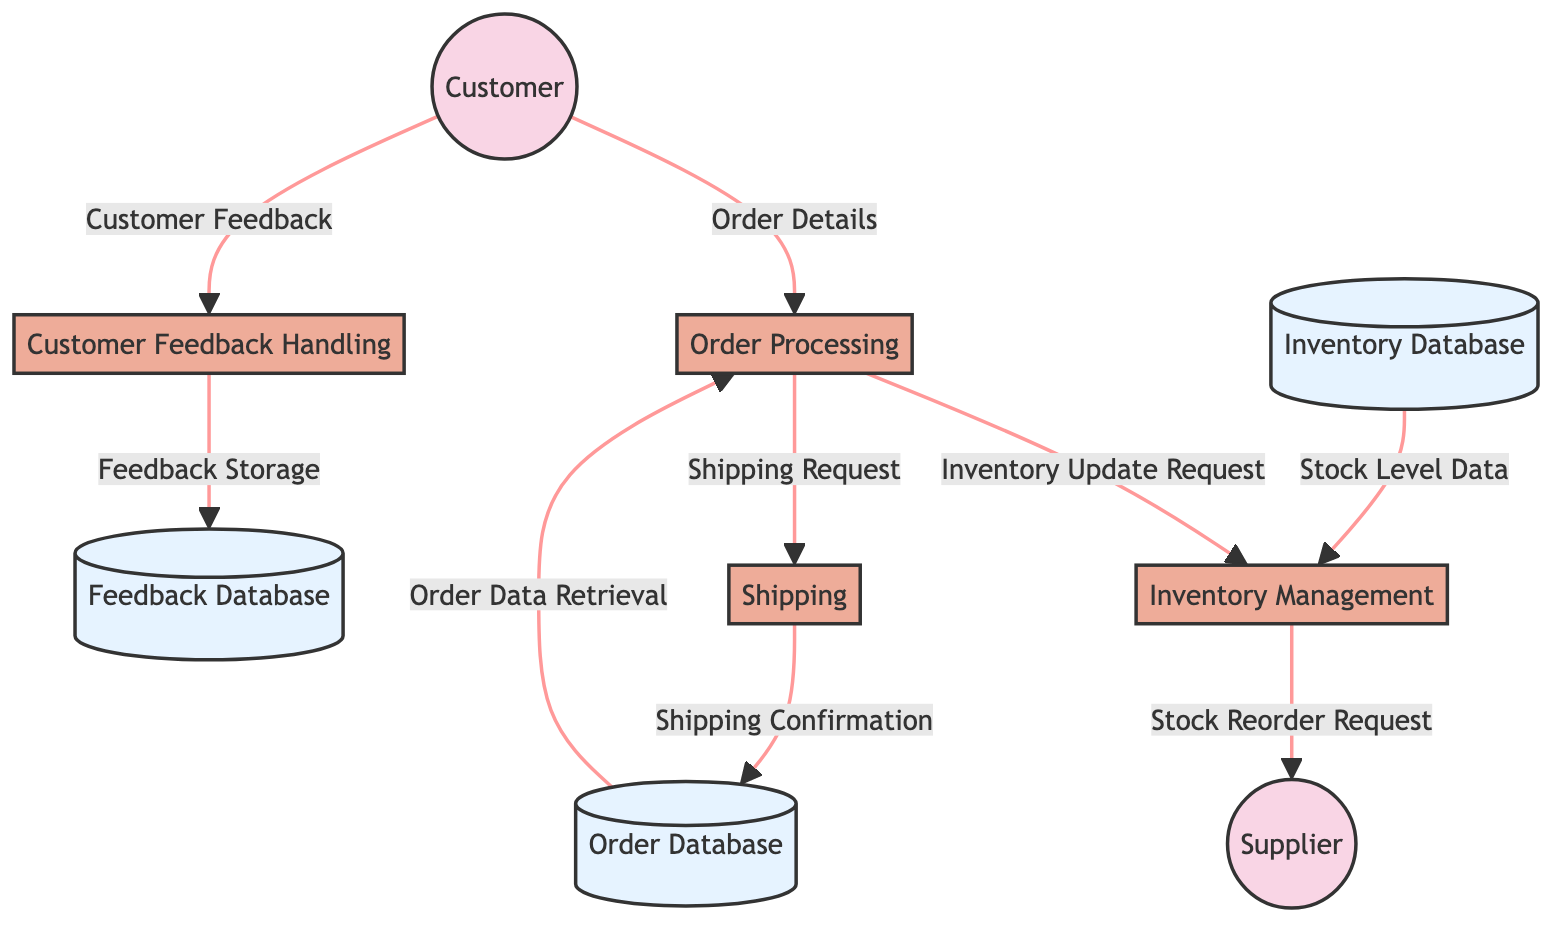What is the name of the process that handles incoming orders? The diagram identifies the process responsible for handling incoming orders as "Order Processing." This information can be easily found by looking at the processes listed in the diagram.
Answer: Order Processing How many external entities are present in the diagram? There are two external entities listed in the diagram: "Customer" and "Supplier." By counting these entities, we conclude the total number.
Answer: 2 What data flow comes from the Customer to the Order Processing? The diagram shows that the data flow labeled "Order Details" originates from the Customer and is directed towards the Order Processing. Therefore, this represents the information exchanged in that data flow.
Answer: Order Details Which process receives the "Stock Level Data"? The "Inventory Management" process receives the "Stock Level Data" as indicated in the data flows section of the diagram. This shows the direction of data from the Inventory Database to the Inventory Management process.
Answer: Inventory Management What is the purpose of the "Customer Feedback Handling" process? The purpose of "Customer Feedback Handling" is described in the diagram as collecting and processing customer feedback post-delivery. This description highlights the role and function of the process.
Answer: Collects and processes customer feedback What request does the "Shipping" process send to the Order Database? The "Shipping Confirmation" is the request that the Shipping process sends to the Order Database, as shown in the data flow connections in the diagram.
Answer: Shipping Confirmation How does the "Order Processing" process interact with the Inventory Management process? The "Order Processing" process interacts with the "Inventory Management" process by sending an "Inventory Update Request." This illustrates a direct connection and the data flow between these two processes.
Answer: Inventory Update Request What is stored in the Feedback Database? The "Feedback Database" stores processed customer feedback as indicated in the description of the data flows. This represents the intended use of this data store according to the diagram.
Answer: Processed customer feedback What action does the Inventory Management process take towards the Supplier? The Inventory Management process sends a "Stock Reorder Request" to the Supplier. This relationship clarifies how inventory needs are communicated outside of the system.
Answer: Stock Reorder Request 